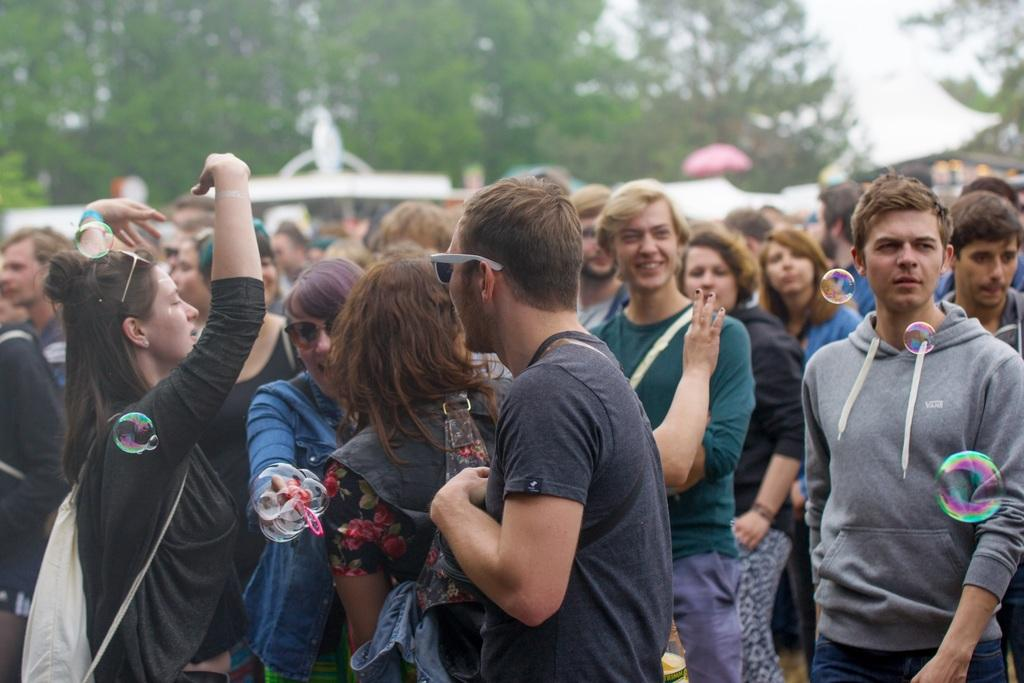What are the people in the image doing? The persons standing on the ground in the image are likely participating in an activity or event. What else can be seen in the image besides the people? There are water bubbles visible in the image. What can be seen in the background of the image? There are tents, trees, and the sky visible in the background of the image. How many cows are present in the image? There are no cows present in the image. What type of furniture can be seen in the brother's bedroom in the image? There is no brother or bedroom present in the image. 